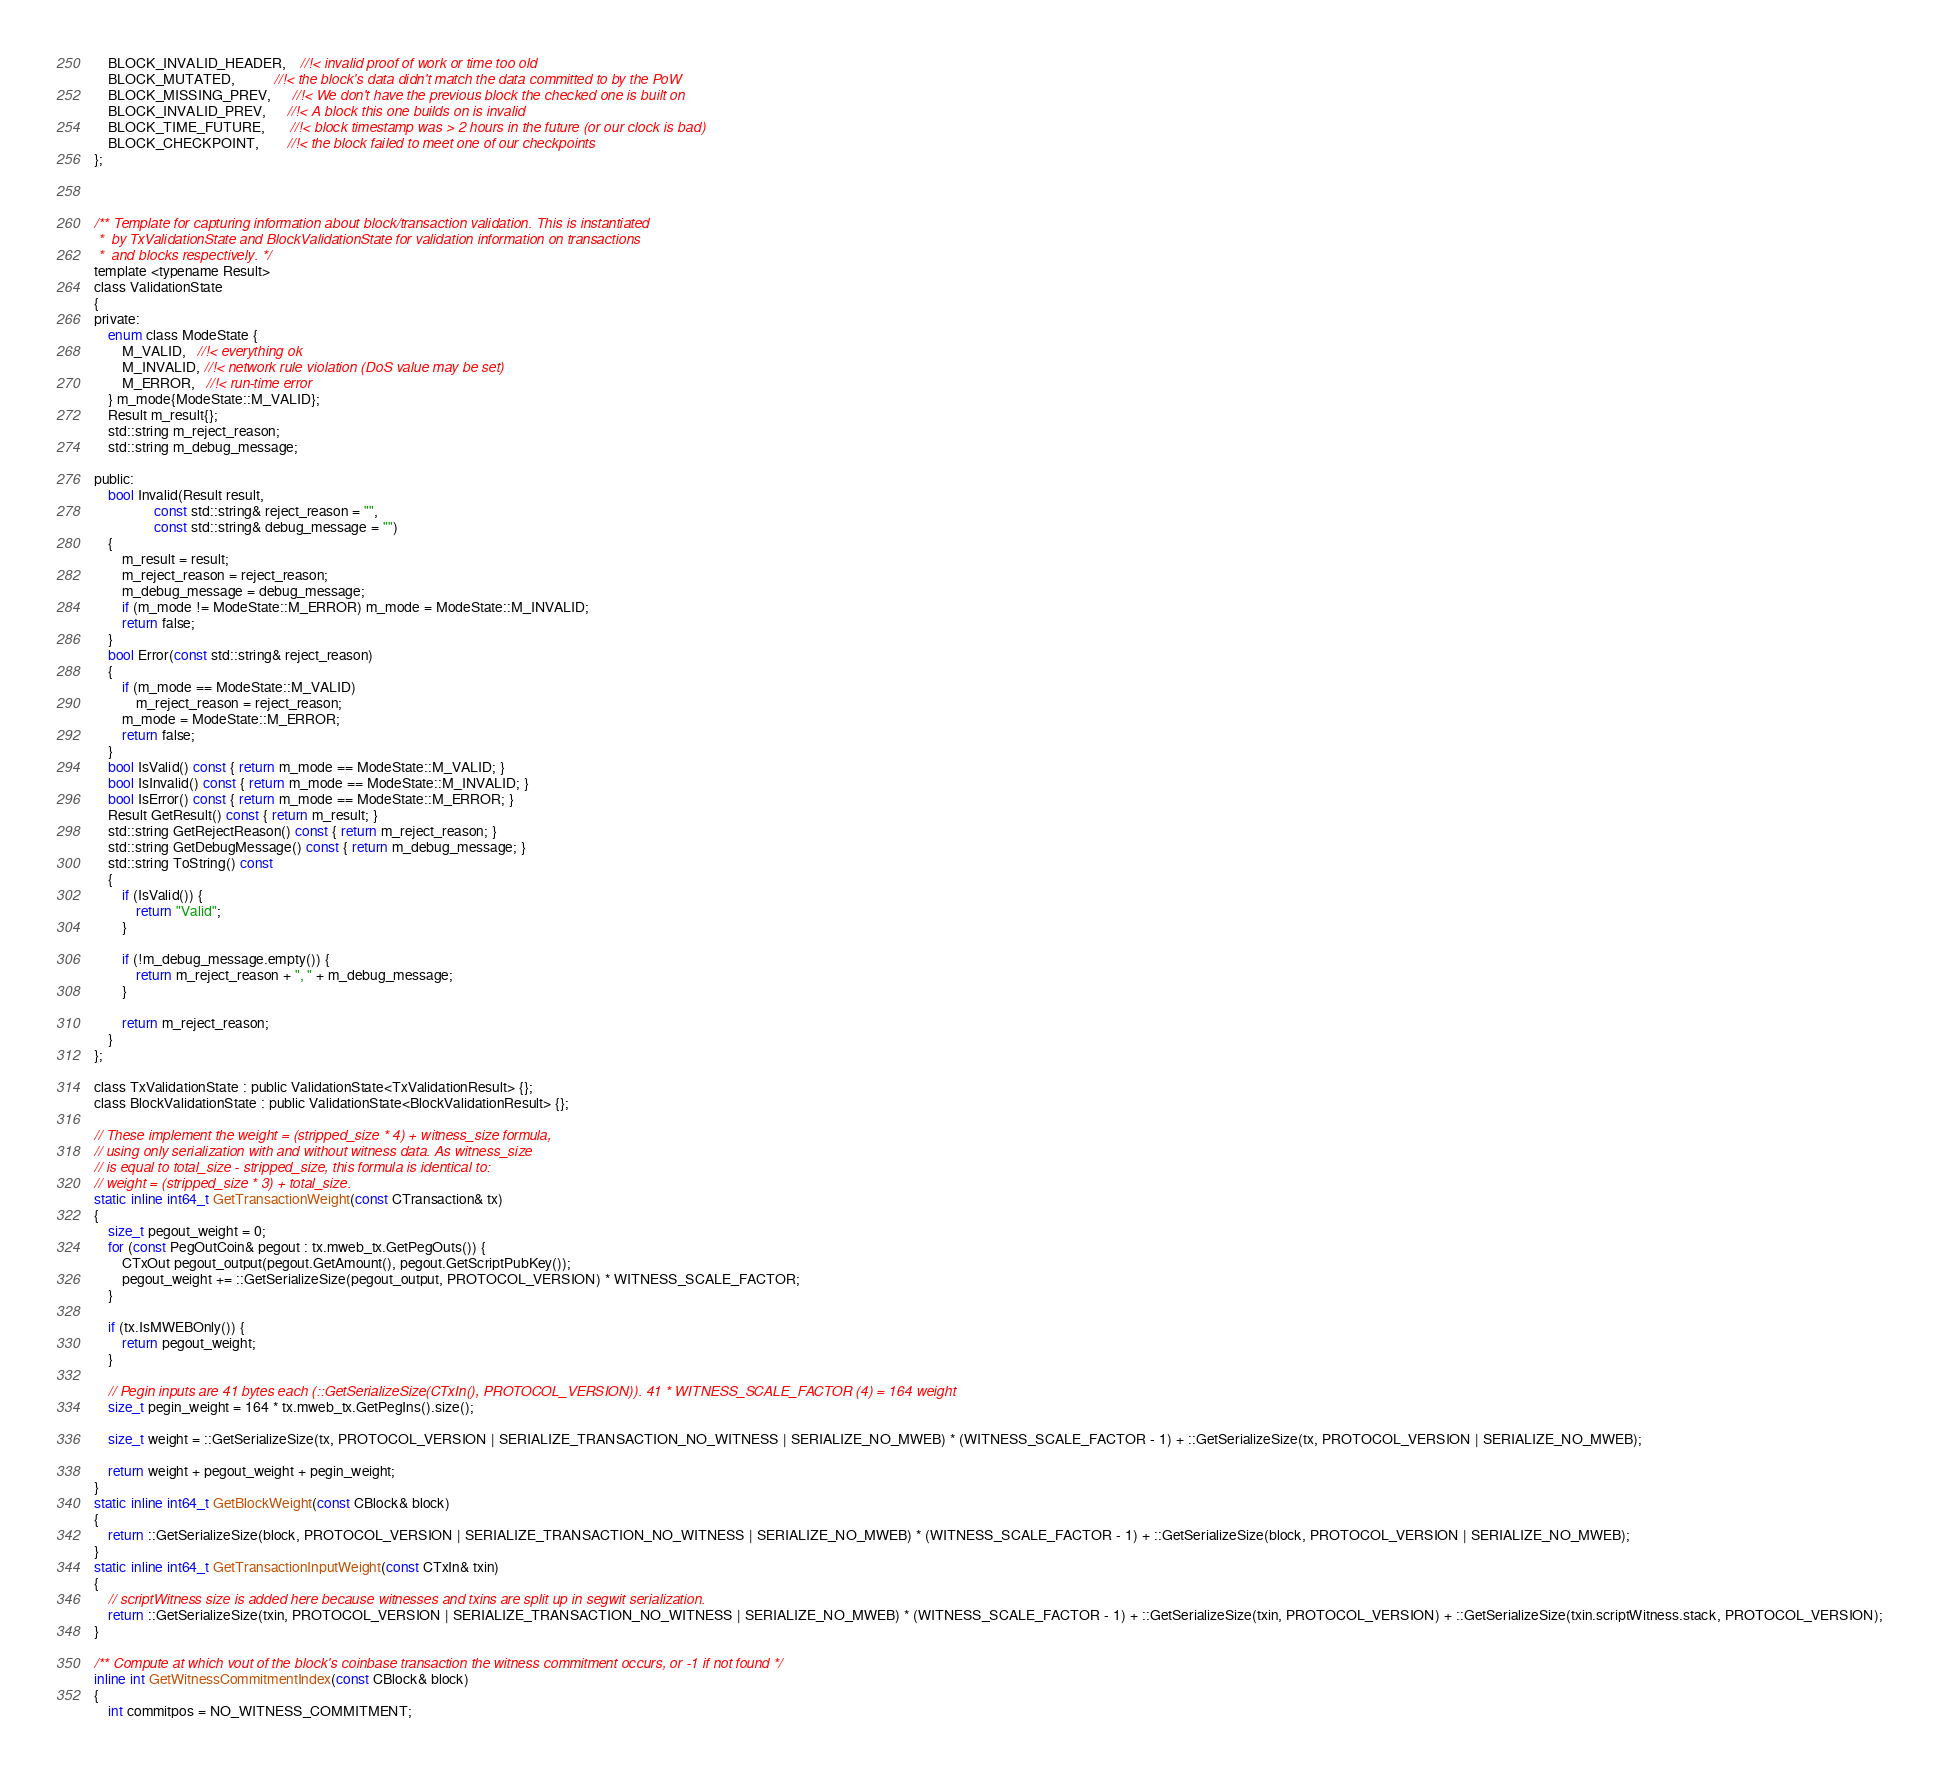Convert code to text. <code><loc_0><loc_0><loc_500><loc_500><_C_>    BLOCK_INVALID_HEADER,    //!< invalid proof of work or time too old
    BLOCK_MUTATED,           //!< the block's data didn't match the data committed to by the PoW
    BLOCK_MISSING_PREV,      //!< We don't have the previous block the checked one is built on
    BLOCK_INVALID_PREV,      //!< A block this one builds on is invalid
    BLOCK_TIME_FUTURE,       //!< block timestamp was > 2 hours in the future (or our clock is bad)
    BLOCK_CHECKPOINT,        //!< the block failed to meet one of our checkpoints
};



/** Template for capturing information about block/transaction validation. This is instantiated
 *  by TxValidationState and BlockValidationState for validation information on transactions
 *  and blocks respectively. */
template <typename Result>
class ValidationState
{
private:
    enum class ModeState {
        M_VALID,   //!< everything ok
        M_INVALID, //!< network rule violation (DoS value may be set)
        M_ERROR,   //!< run-time error
    } m_mode{ModeState::M_VALID};
    Result m_result{};
    std::string m_reject_reason;
    std::string m_debug_message;

public:
    bool Invalid(Result result,
                 const std::string& reject_reason = "",
                 const std::string& debug_message = "")
    {
        m_result = result;
        m_reject_reason = reject_reason;
        m_debug_message = debug_message;
        if (m_mode != ModeState::M_ERROR) m_mode = ModeState::M_INVALID;
        return false;
    }
    bool Error(const std::string& reject_reason)
    {
        if (m_mode == ModeState::M_VALID)
            m_reject_reason = reject_reason;
        m_mode = ModeState::M_ERROR;
        return false;
    }
    bool IsValid() const { return m_mode == ModeState::M_VALID; }
    bool IsInvalid() const { return m_mode == ModeState::M_INVALID; }
    bool IsError() const { return m_mode == ModeState::M_ERROR; }
    Result GetResult() const { return m_result; }
    std::string GetRejectReason() const { return m_reject_reason; }
    std::string GetDebugMessage() const { return m_debug_message; }
    std::string ToString() const
    {
        if (IsValid()) {
            return "Valid";
        }

        if (!m_debug_message.empty()) {
            return m_reject_reason + ", " + m_debug_message;
        }

        return m_reject_reason;
    }
};

class TxValidationState : public ValidationState<TxValidationResult> {};
class BlockValidationState : public ValidationState<BlockValidationResult> {};

// These implement the weight = (stripped_size * 4) + witness_size formula,
// using only serialization with and without witness data. As witness_size
// is equal to total_size - stripped_size, this formula is identical to:
// weight = (stripped_size * 3) + total_size.
static inline int64_t GetTransactionWeight(const CTransaction& tx)
{
    size_t pegout_weight = 0;
    for (const PegOutCoin& pegout : tx.mweb_tx.GetPegOuts()) {
        CTxOut pegout_output(pegout.GetAmount(), pegout.GetScriptPubKey());
        pegout_weight += ::GetSerializeSize(pegout_output, PROTOCOL_VERSION) * WITNESS_SCALE_FACTOR;
    }

    if (tx.IsMWEBOnly()) {
        return pegout_weight;
    }

    // Pegin inputs are 41 bytes each (::GetSerializeSize(CTxIn(), PROTOCOL_VERSION)). 41 * WITNESS_SCALE_FACTOR (4) = 164 weight
    size_t pegin_weight = 164 * tx.mweb_tx.GetPegIns().size();

    size_t weight = ::GetSerializeSize(tx, PROTOCOL_VERSION | SERIALIZE_TRANSACTION_NO_WITNESS | SERIALIZE_NO_MWEB) * (WITNESS_SCALE_FACTOR - 1) + ::GetSerializeSize(tx, PROTOCOL_VERSION | SERIALIZE_NO_MWEB);
    
    return weight + pegout_weight + pegin_weight;
}
static inline int64_t GetBlockWeight(const CBlock& block)
{
    return ::GetSerializeSize(block, PROTOCOL_VERSION | SERIALIZE_TRANSACTION_NO_WITNESS | SERIALIZE_NO_MWEB) * (WITNESS_SCALE_FACTOR - 1) + ::GetSerializeSize(block, PROTOCOL_VERSION | SERIALIZE_NO_MWEB);
}
static inline int64_t GetTransactionInputWeight(const CTxIn& txin)
{
    // scriptWitness size is added here because witnesses and txins are split up in segwit serialization.
    return ::GetSerializeSize(txin, PROTOCOL_VERSION | SERIALIZE_TRANSACTION_NO_WITNESS | SERIALIZE_NO_MWEB) * (WITNESS_SCALE_FACTOR - 1) + ::GetSerializeSize(txin, PROTOCOL_VERSION) + ::GetSerializeSize(txin.scriptWitness.stack, PROTOCOL_VERSION);
}

/** Compute at which vout of the block's coinbase transaction the witness commitment occurs, or -1 if not found */
inline int GetWitnessCommitmentIndex(const CBlock& block)
{
    int commitpos = NO_WITNESS_COMMITMENT;</code> 